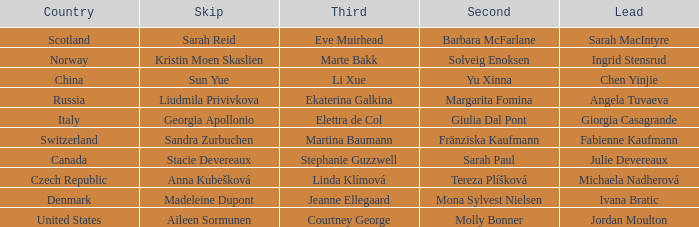Which skip lists denmark as its country? Madeleine Dupont. 